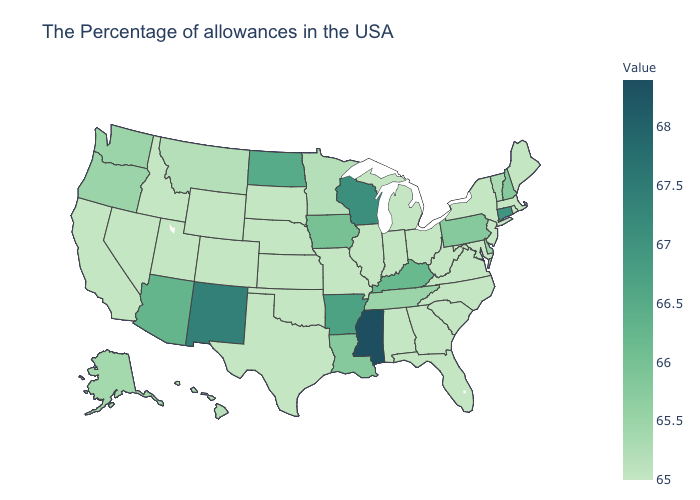Does Massachusetts have the lowest value in the USA?
Concise answer only. Yes. Among the states that border Illinois , does Missouri have the lowest value?
Be succinct. Yes. Does Tennessee have the lowest value in the South?
Keep it brief. No. 